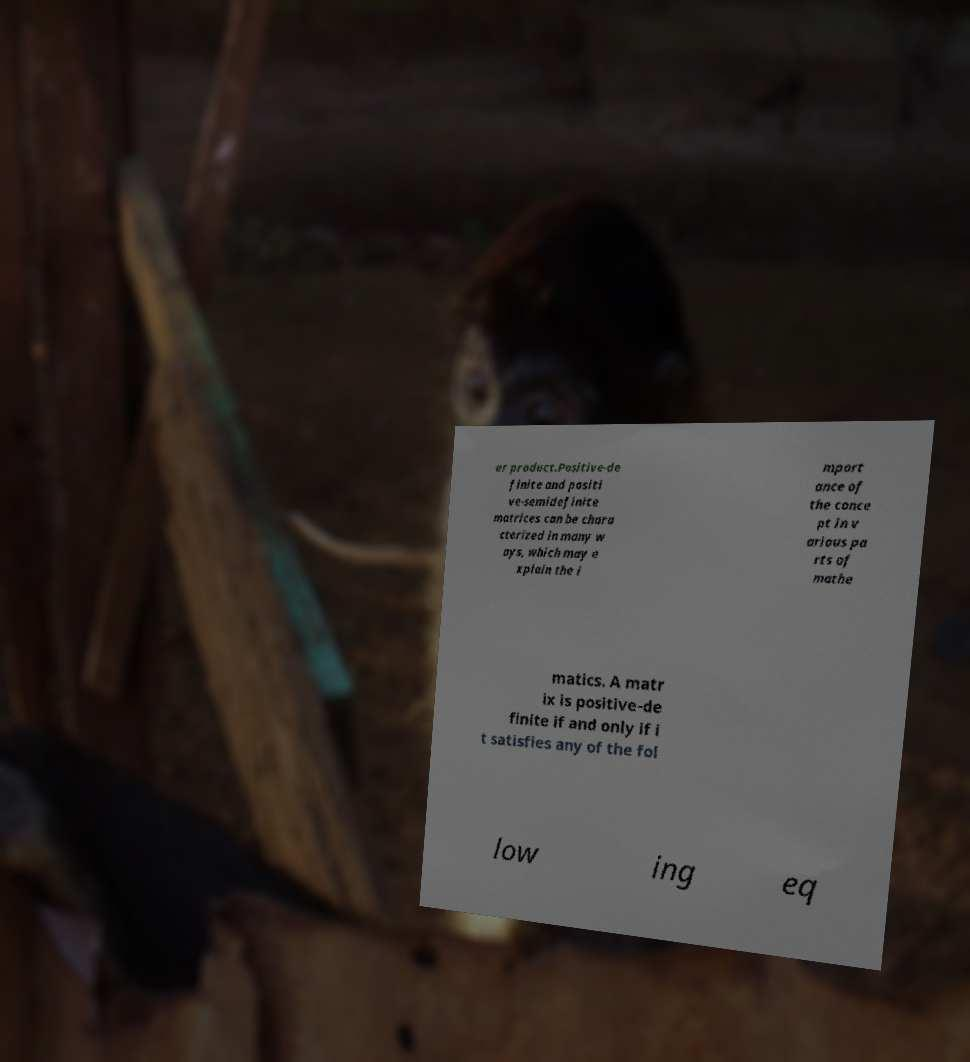Can you read and provide the text displayed in the image?This photo seems to have some interesting text. Can you extract and type it out for me? er product.Positive-de finite and positi ve-semidefinite matrices can be chara cterized in many w ays, which may e xplain the i mport ance of the conce pt in v arious pa rts of mathe matics. A matr ix is positive-de finite if and only if i t satisfies any of the fol low ing eq 